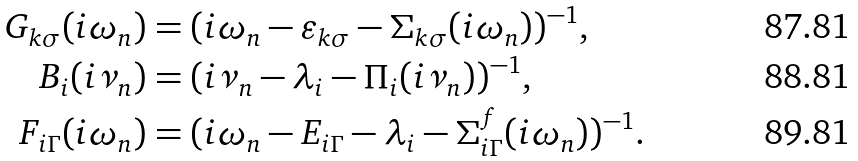Convert formula to latex. <formula><loc_0><loc_0><loc_500><loc_500>G _ { { k } \sigma } ( i \omega _ { n } ) & = ( i \omega _ { n } - \varepsilon _ { k \sigma } - \Sigma _ { { k } \sigma } ( i \omega _ { n } ) ) ^ { - 1 } , \\ B _ { i } ( i \nu _ { n } ) & = ( i \nu _ { n } - \lambda _ { i } - \Pi _ { i } ( i \nu _ { n } ) ) ^ { - 1 } , \\ F _ { i \Gamma } ( i \omega _ { n } ) & = ( i \omega _ { n } - E _ { i \Gamma } - \lambda _ { i } - \Sigma ^ { f } _ { i \Gamma } ( i \omega _ { n } ) ) ^ { - 1 } .</formula> 